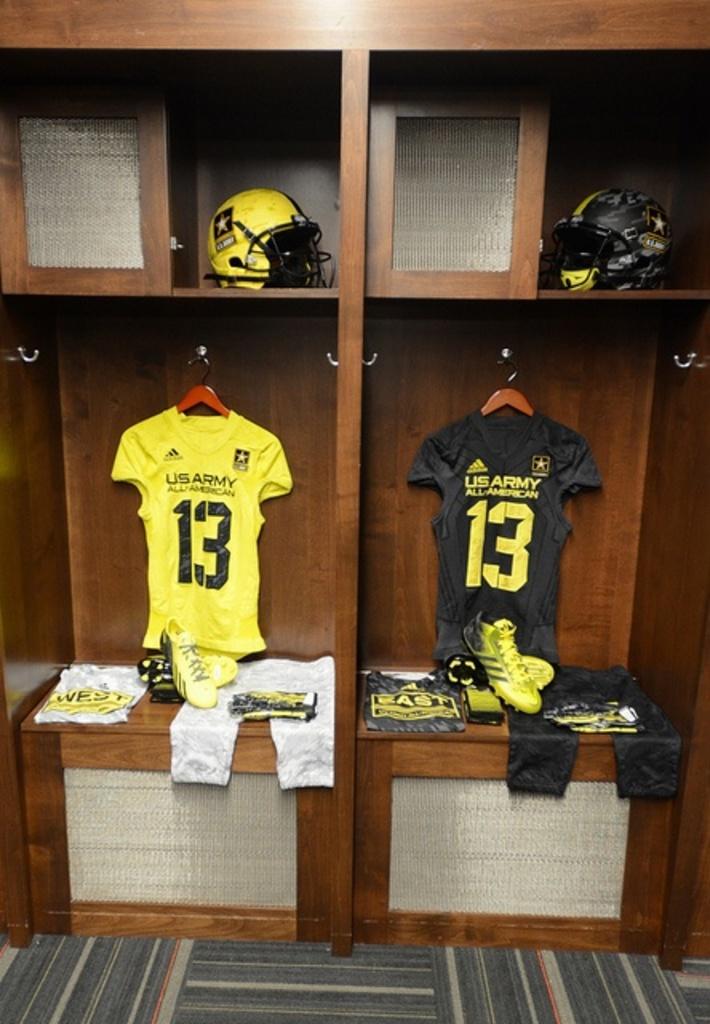What team are the jerseys for?
Offer a very short reply. Us army. 